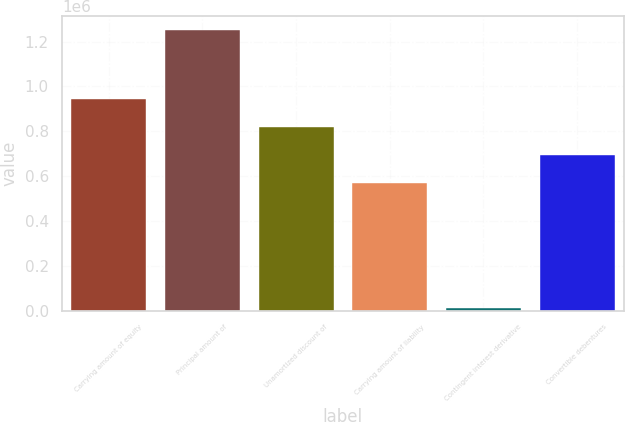<chart> <loc_0><loc_0><loc_500><loc_500><bar_chart><fcel>Carrying amount of equity<fcel>Principal amount of<fcel>Unamortized discount of<fcel>Carrying amount of liability<fcel>Contingent interest derivative<fcel>Convertible debentures<nl><fcel>942976<fcel>1.25e+06<fcel>819026<fcel>571126<fcel>10500<fcel>695076<nl></chart> 